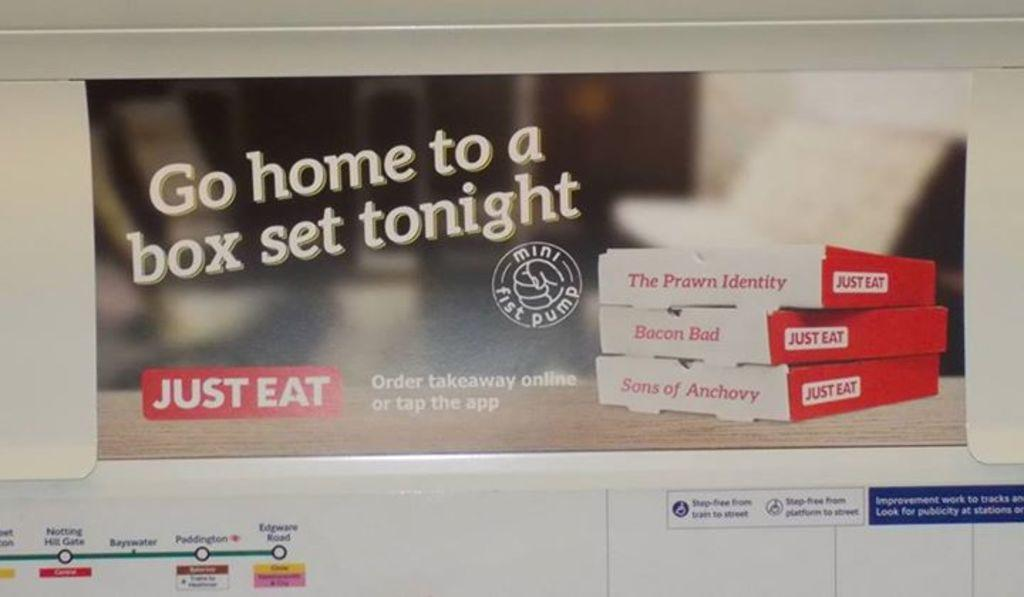<image>
Share a concise interpretation of the image provided. An ad saying go home to a box set tonight just eat 